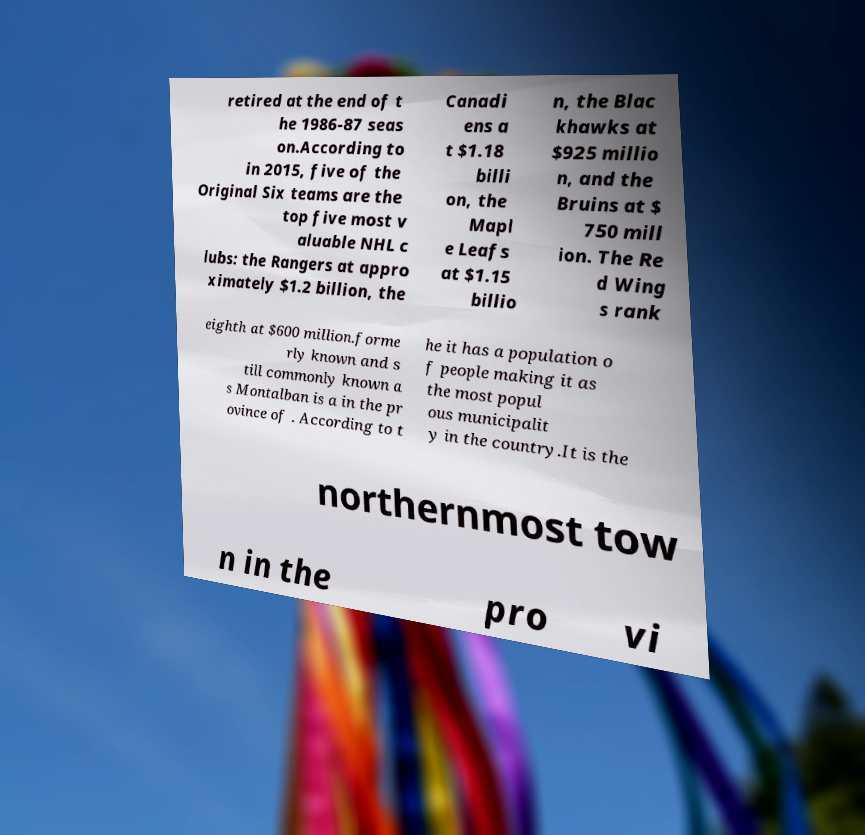Could you assist in decoding the text presented in this image and type it out clearly? retired at the end of t he 1986-87 seas on.According to in 2015, five of the Original Six teams are the top five most v aluable NHL c lubs: the Rangers at appro ximately $1.2 billion, the Canadi ens a t $1.18 billi on, the Mapl e Leafs at $1.15 billio n, the Blac khawks at $925 millio n, and the Bruins at $ 750 mill ion. The Re d Wing s rank eighth at $600 million.forme rly known and s till commonly known a s Montalban is a in the pr ovince of . According to t he it has a population o f people making it as the most popul ous municipalit y in the country.It is the northernmost tow n in the pro vi 